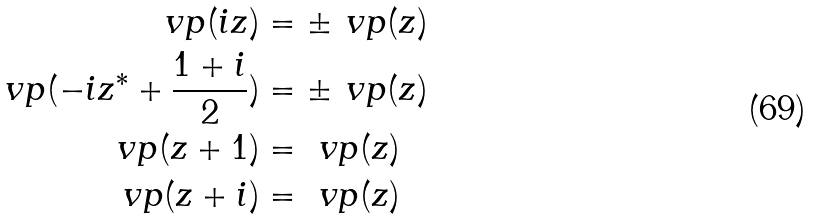Convert formula to latex. <formula><loc_0><loc_0><loc_500><loc_500>\ v p ( i z ) & = \pm \ v p ( z ) \\ \ v p ( - i z ^ { * } + \frac { 1 + i } { 2 } ) & = \pm \ v p ( z ) \\ \ v p ( z + 1 ) & = \ v p ( z ) \\ \ v p ( z + i ) & = \ v p ( z )</formula> 